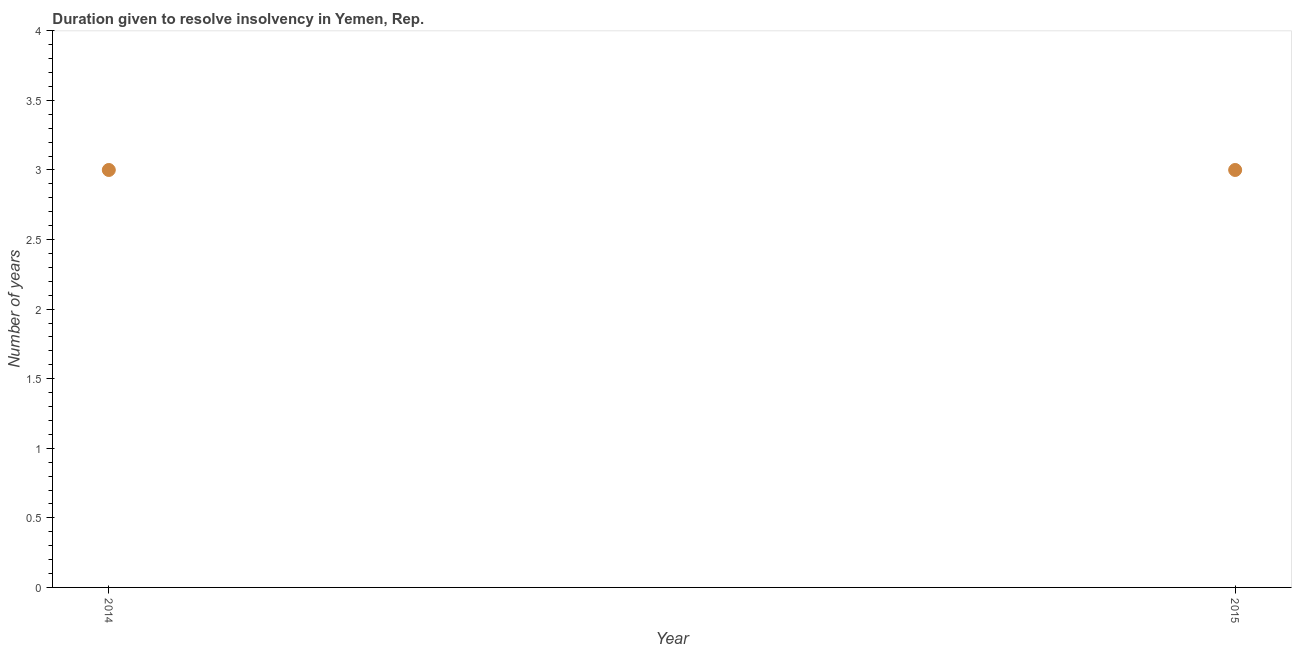What is the number of years to resolve insolvency in 2014?
Give a very brief answer. 3. Across all years, what is the maximum number of years to resolve insolvency?
Offer a terse response. 3. Across all years, what is the minimum number of years to resolve insolvency?
Give a very brief answer. 3. In which year was the number of years to resolve insolvency maximum?
Make the answer very short. 2014. In which year was the number of years to resolve insolvency minimum?
Your answer should be very brief. 2014. What is the average number of years to resolve insolvency per year?
Offer a very short reply. 3. What is the median number of years to resolve insolvency?
Make the answer very short. 3. How many dotlines are there?
Offer a terse response. 1. How many years are there in the graph?
Your response must be concise. 2. Are the values on the major ticks of Y-axis written in scientific E-notation?
Offer a terse response. No. Does the graph contain grids?
Give a very brief answer. No. What is the title of the graph?
Your response must be concise. Duration given to resolve insolvency in Yemen, Rep. What is the label or title of the X-axis?
Give a very brief answer. Year. What is the label or title of the Y-axis?
Offer a very short reply. Number of years. What is the Number of years in 2015?
Offer a terse response. 3. 